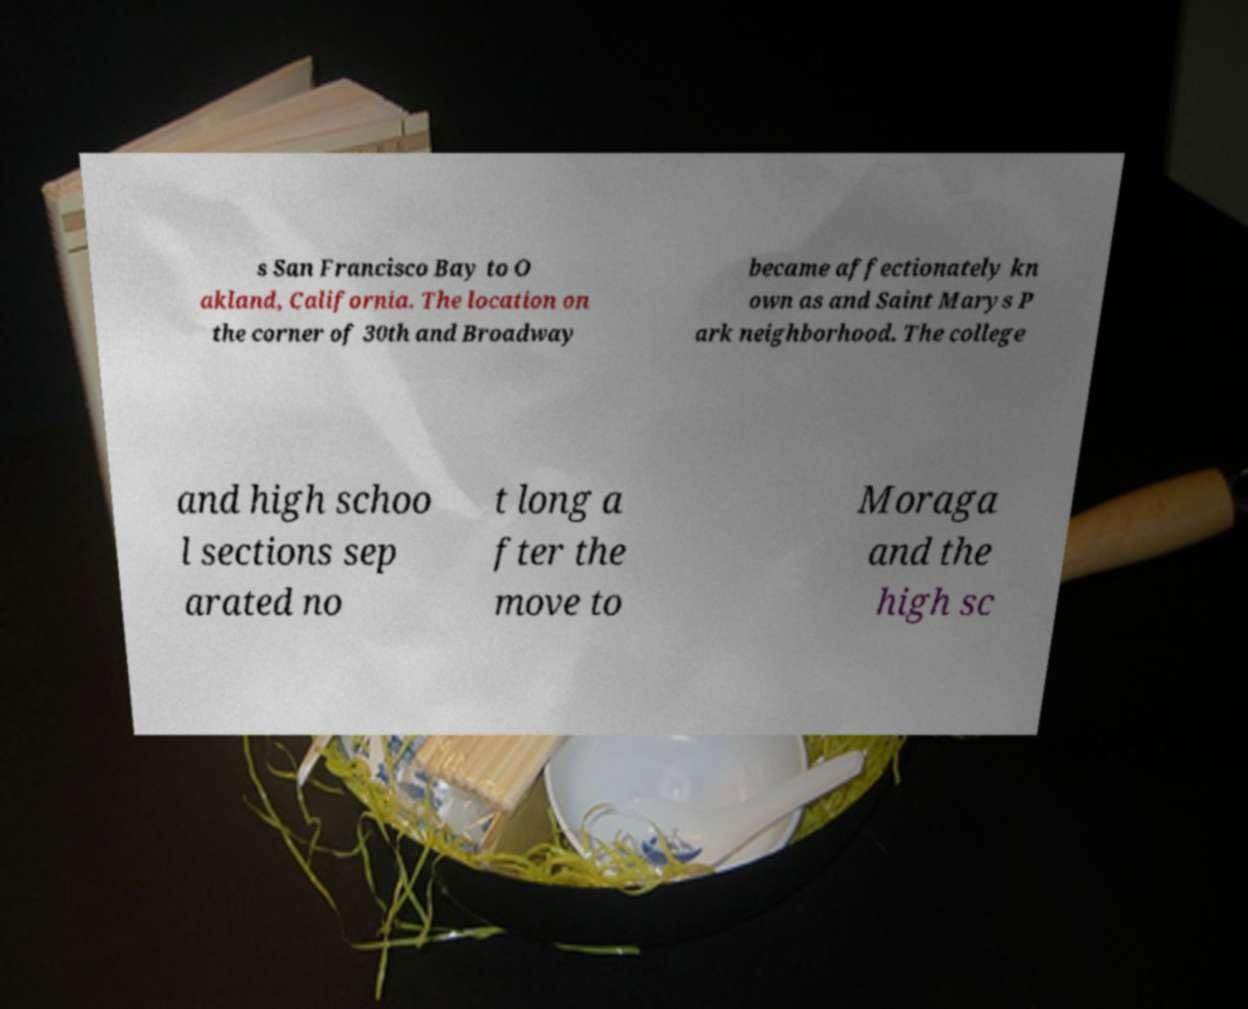Please read and relay the text visible in this image. What does it say? s San Francisco Bay to O akland, California. The location on the corner of 30th and Broadway became affectionately kn own as and Saint Marys P ark neighborhood. The college and high schoo l sections sep arated no t long a fter the move to Moraga and the high sc 